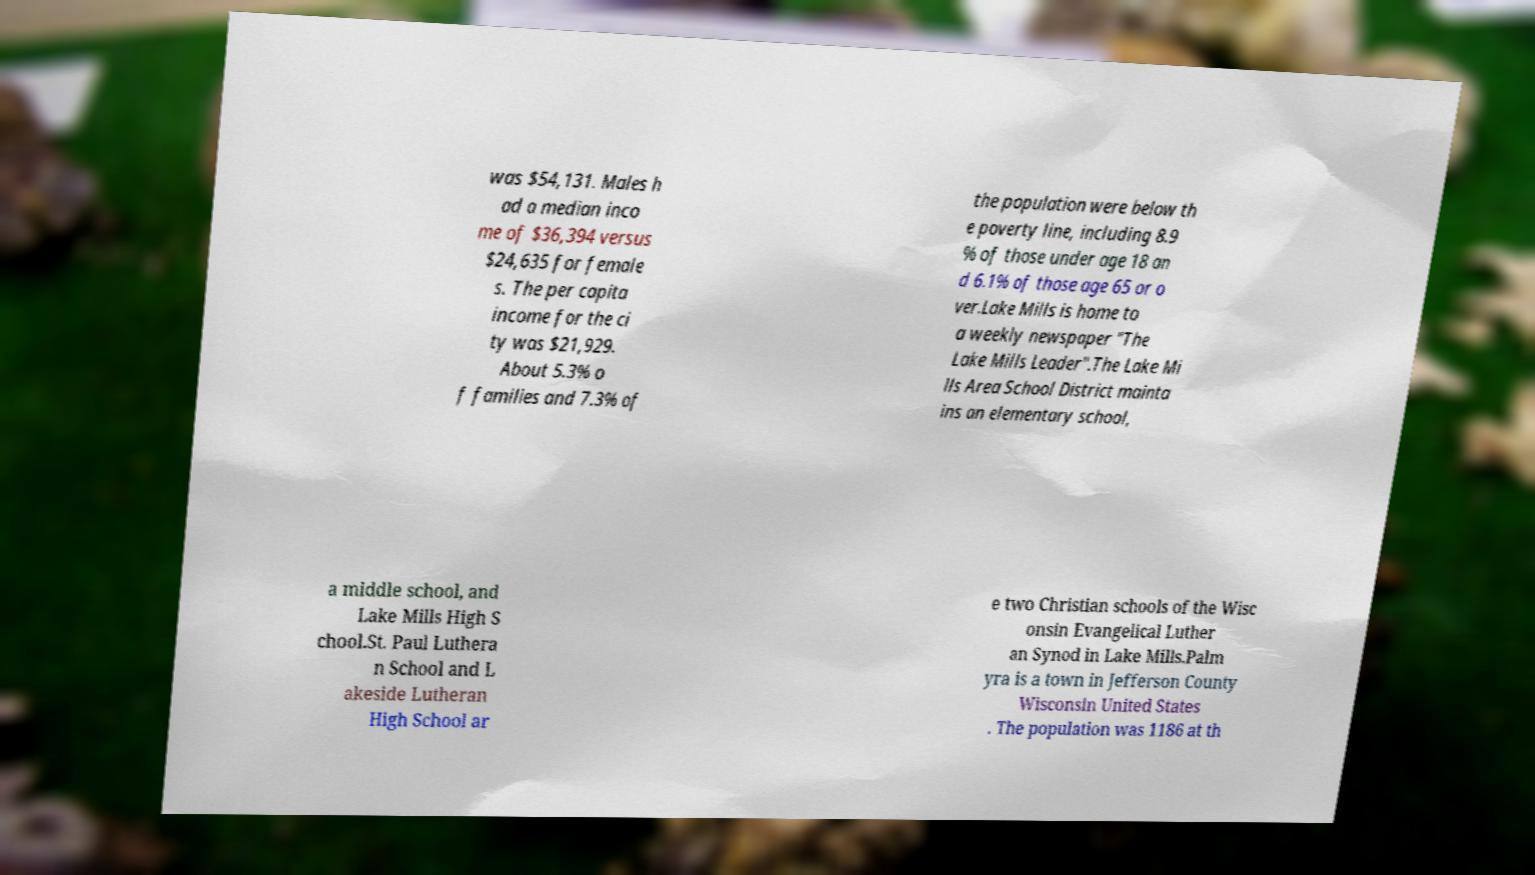Can you accurately transcribe the text from the provided image for me? was $54,131. Males h ad a median inco me of $36,394 versus $24,635 for female s. The per capita income for the ci ty was $21,929. About 5.3% o f families and 7.3% of the population were below th e poverty line, including 8.9 % of those under age 18 an d 6.1% of those age 65 or o ver.Lake Mills is home to a weekly newspaper "The Lake Mills Leader".The Lake Mi lls Area School District mainta ins an elementary school, a middle school, and Lake Mills High S chool.St. Paul Luthera n School and L akeside Lutheran High School ar e two Christian schools of the Wisc onsin Evangelical Luther an Synod in Lake Mills.Palm yra is a town in Jefferson County Wisconsin United States . The population was 1186 at th 